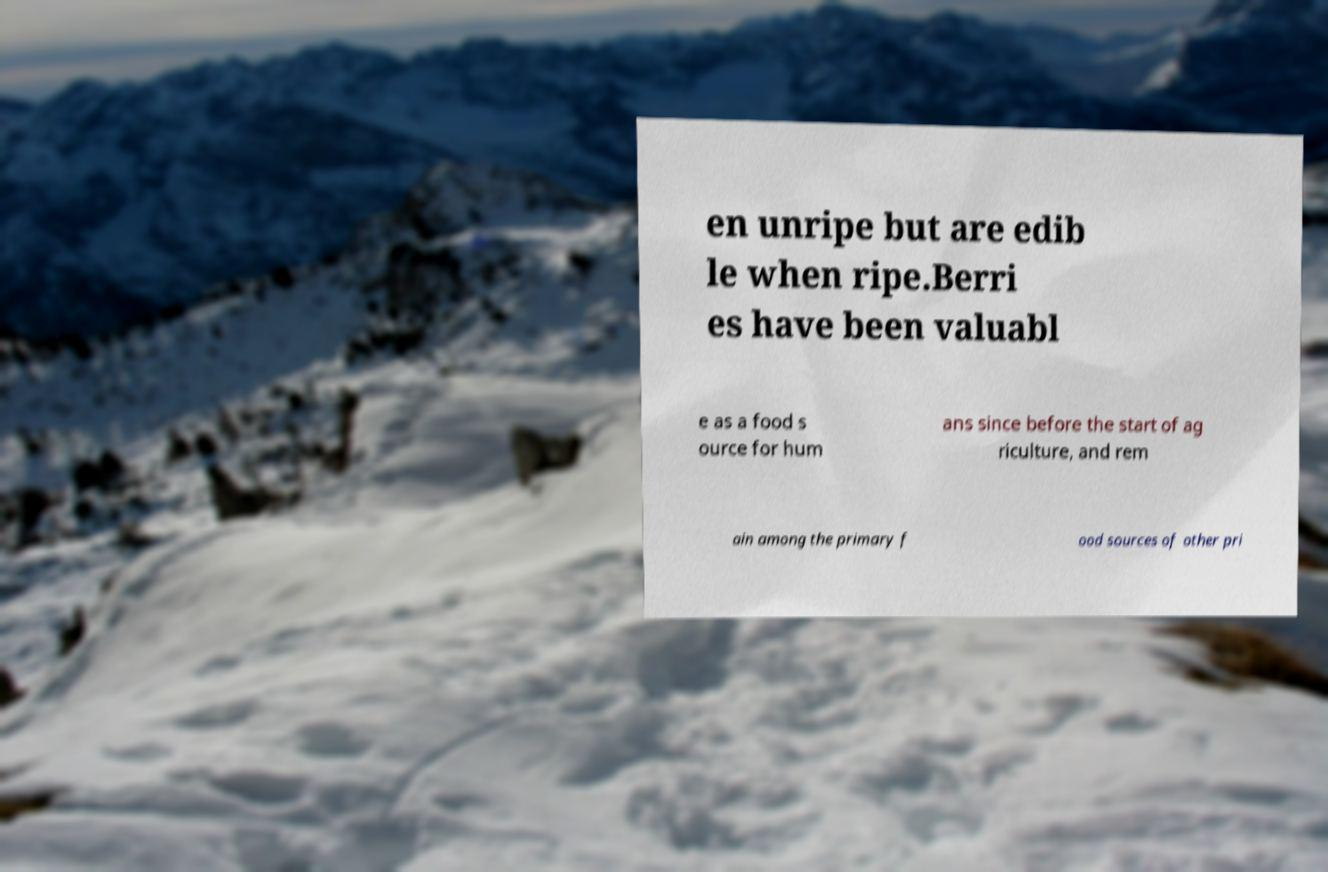Could you extract and type out the text from this image? en unripe but are edib le when ripe.Berri es have been valuabl e as a food s ource for hum ans since before the start of ag riculture, and rem ain among the primary f ood sources of other pri 